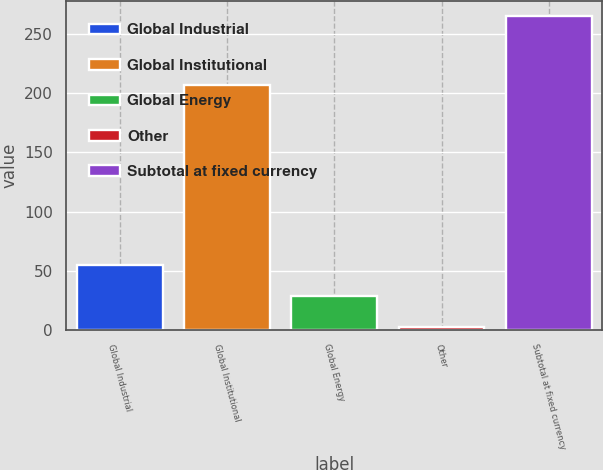<chart> <loc_0><loc_0><loc_500><loc_500><bar_chart><fcel>Global Industrial<fcel>Global Institutional<fcel>Global Energy<fcel>Other<fcel>Subtotal at fixed currency<nl><fcel>54.72<fcel>207.4<fcel>28.41<fcel>2.1<fcel>265.2<nl></chart> 